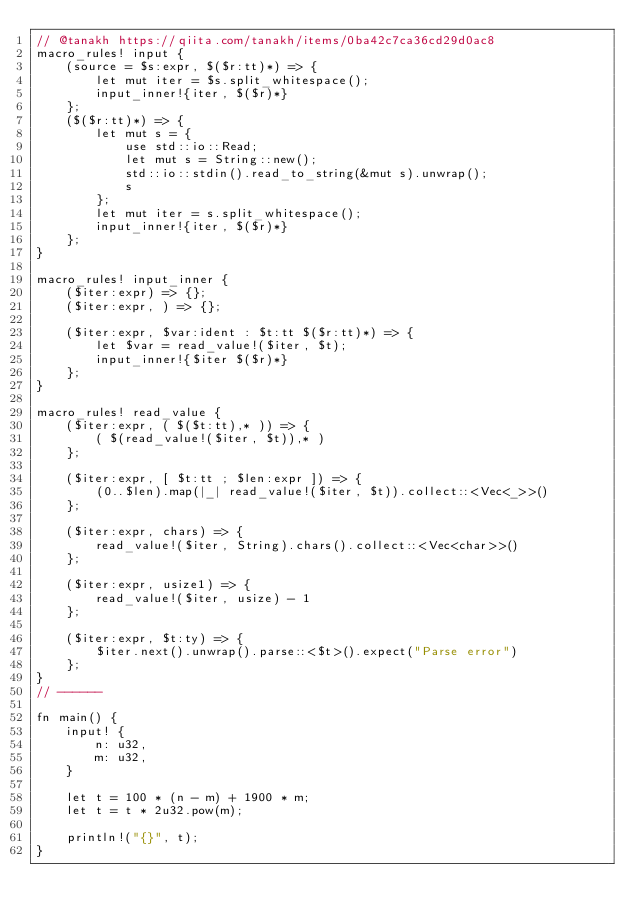<code> <loc_0><loc_0><loc_500><loc_500><_Rust_>// @tanakh https://qiita.com/tanakh/items/0ba42c7ca36cd29d0ac8
macro_rules! input {
    (source = $s:expr, $($r:tt)*) => {
        let mut iter = $s.split_whitespace();
        input_inner!{iter, $($r)*}
    };
    ($($r:tt)*) => {
        let mut s = {
            use std::io::Read;
            let mut s = String::new();
            std::io::stdin().read_to_string(&mut s).unwrap();
            s
        };
        let mut iter = s.split_whitespace();
        input_inner!{iter, $($r)*}
    };
}

macro_rules! input_inner {
    ($iter:expr) => {};
    ($iter:expr, ) => {};

    ($iter:expr, $var:ident : $t:tt $($r:tt)*) => {
        let $var = read_value!($iter, $t);
        input_inner!{$iter $($r)*}
    };
}

macro_rules! read_value {
    ($iter:expr, ( $($t:tt),* )) => {
        ( $(read_value!($iter, $t)),* )
    };

    ($iter:expr, [ $t:tt ; $len:expr ]) => {
        (0..$len).map(|_| read_value!($iter, $t)).collect::<Vec<_>>()
    };

    ($iter:expr, chars) => {
        read_value!($iter, String).chars().collect::<Vec<char>>()
    };

    ($iter:expr, usize1) => {
        read_value!($iter, usize) - 1
    };

    ($iter:expr, $t:ty) => {
        $iter.next().unwrap().parse::<$t>().expect("Parse error")
    };
}
// ------

fn main() {
    input! {
        n: u32,
        m: u32,
    }

    let t = 100 * (n - m) + 1900 * m;
    let t = t * 2u32.pow(m);

    println!("{}", t);
}
</code> 